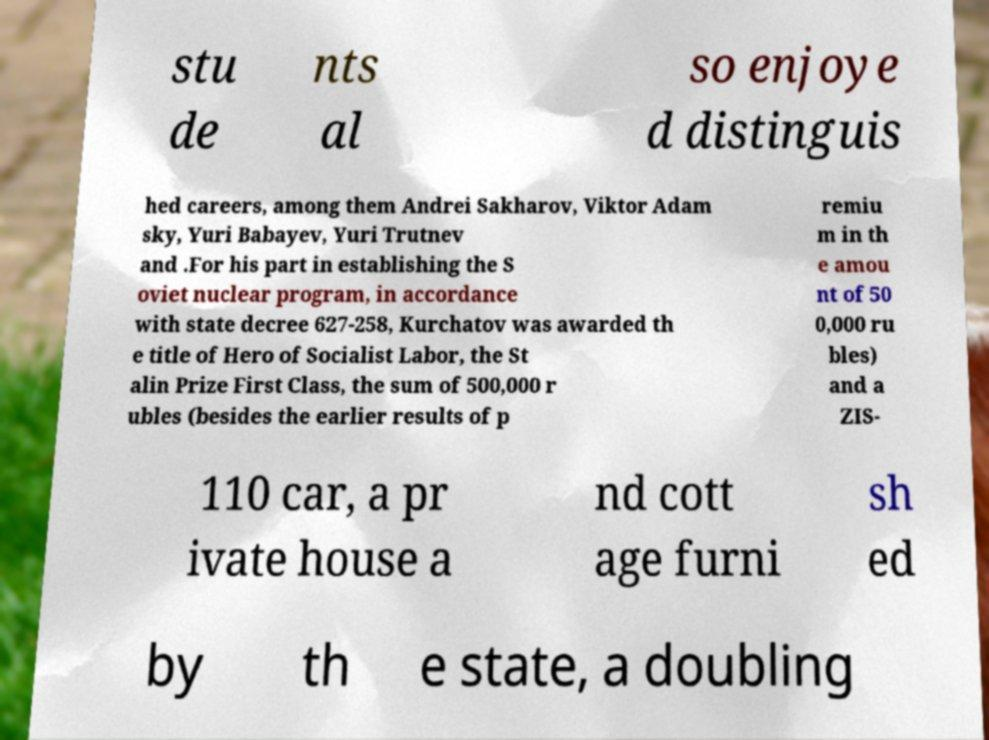What messages or text are displayed in this image? I need them in a readable, typed format. stu de nts al so enjoye d distinguis hed careers, among them Andrei Sakharov, Viktor Adam sky, Yuri Babayev, Yuri Trutnev and .For his part in establishing the S oviet nuclear program, in accordance with state decree 627-258, Kurchatov was awarded th e title of Hero of Socialist Labor, the St alin Prize First Class, the sum of 500,000 r ubles (besides the earlier results of p remiu m in th e amou nt of 50 0,000 ru bles) and a ZIS- 110 car, a pr ivate house a nd cott age furni sh ed by th e state, a doubling 